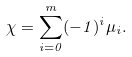<formula> <loc_0><loc_0><loc_500><loc_500>\chi = \sum _ { i = 0 } ^ { m } ( - 1 ) ^ { i } \mu _ { i } .</formula> 